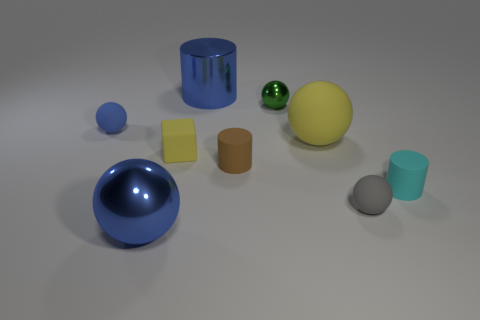Are there any brown objects of the same size as the green thing?
Your answer should be compact. Yes. How many yellow things are the same shape as the small gray object?
Your response must be concise. 1. Is the number of matte blocks to the left of the tiny blue matte thing the same as the number of blue things that are on the left side of the large blue ball?
Provide a succinct answer. No. Are there any tiny cyan metallic spheres?
Provide a short and direct response. No. How big is the blue thing that is to the right of the shiny ball that is in front of the yellow object that is in front of the yellow matte sphere?
Give a very brief answer. Large. The gray object that is the same size as the brown matte thing is what shape?
Ensure brevity in your answer.  Sphere. How many objects are yellow things that are in front of the large yellow object or big yellow spheres?
Provide a succinct answer. 2. Are there any large blue spheres that are left of the blue metallic thing on the right side of the big metallic thing that is in front of the gray rubber sphere?
Your answer should be compact. Yes. What number of blue cylinders are there?
Provide a short and direct response. 1. What number of things are either cylinders that are on the right side of the gray rubber sphere or tiny balls that are on the right side of the brown matte object?
Keep it short and to the point. 3. 